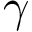<formula> <loc_0><loc_0><loc_500><loc_500>\gamma</formula> 